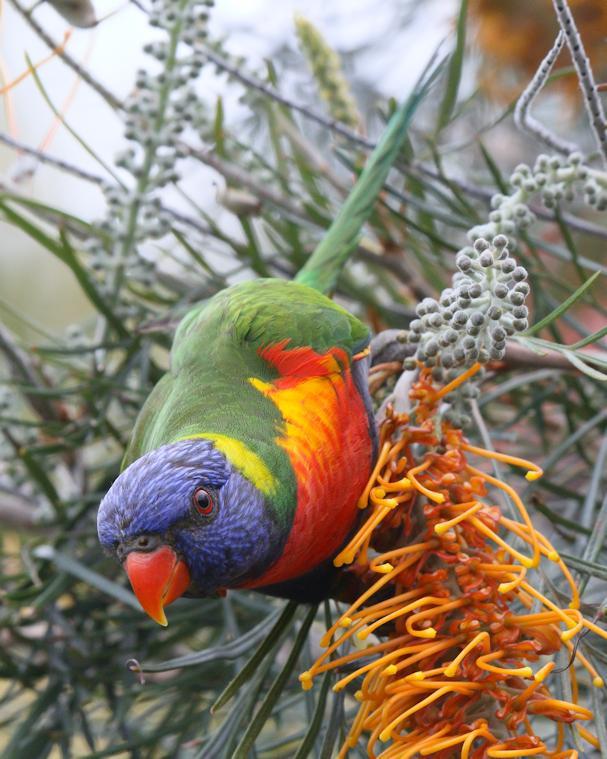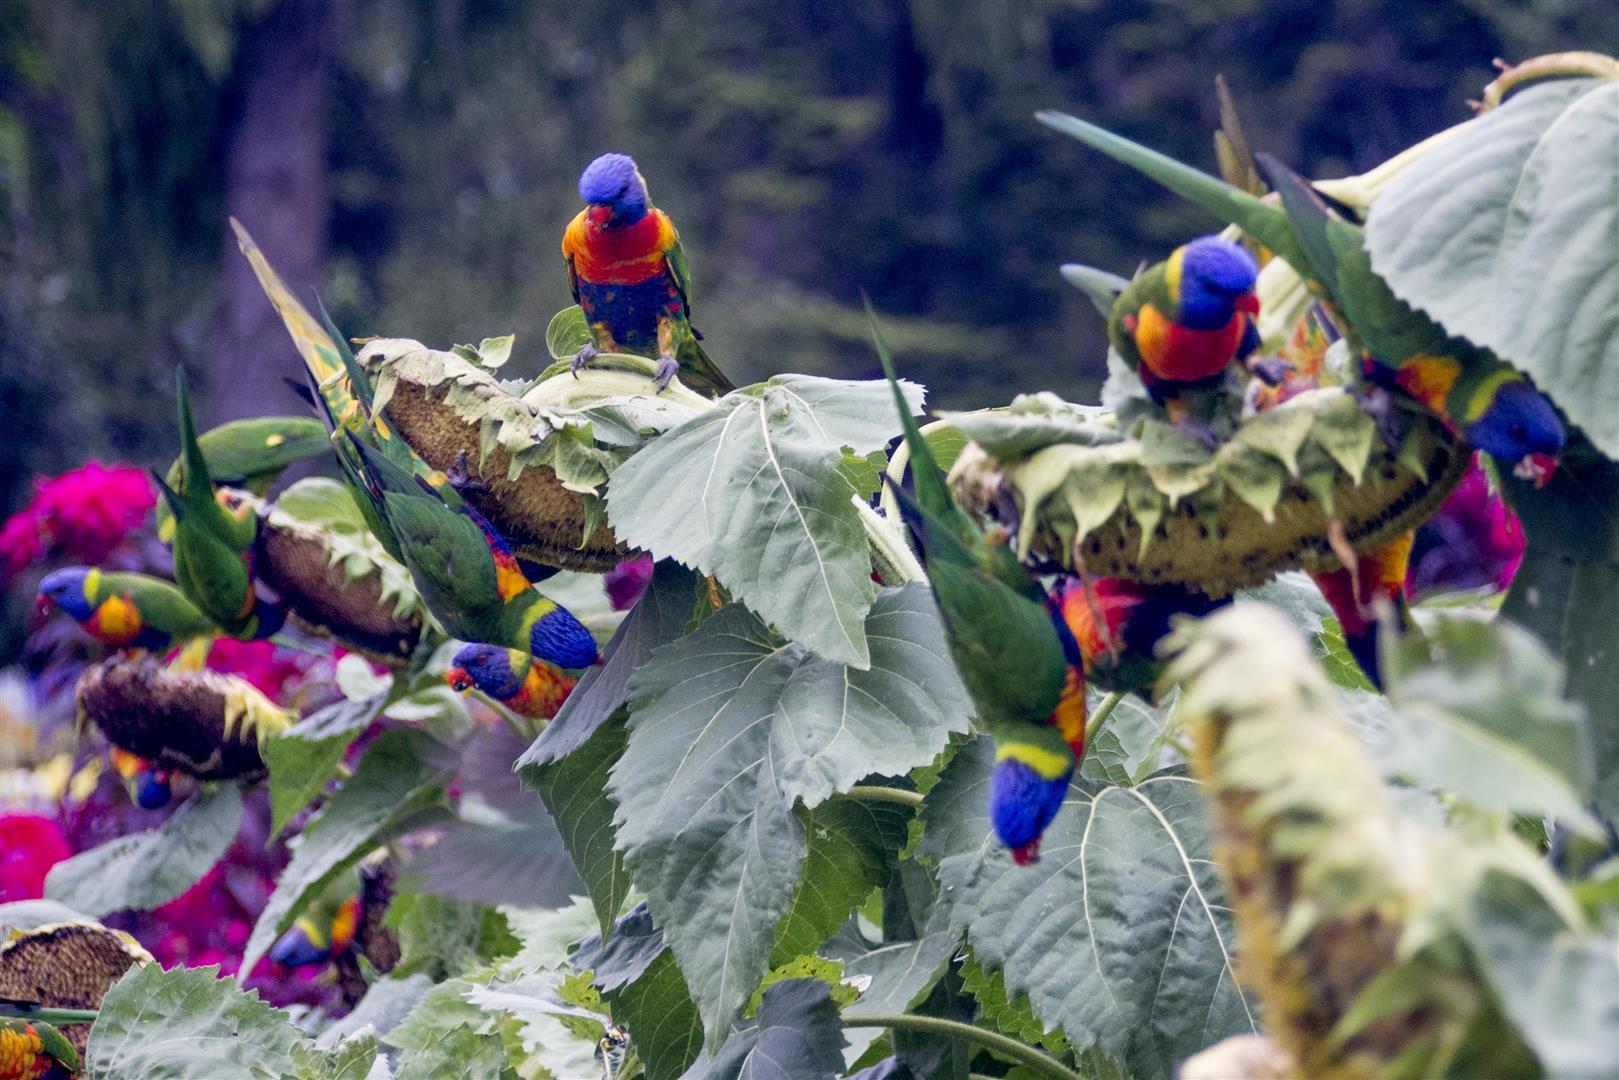The first image is the image on the left, the second image is the image on the right. Evaluate the accuracy of this statement regarding the images: "There are at least two birds in the image on the left.". Is it true? Answer yes or no. No. 